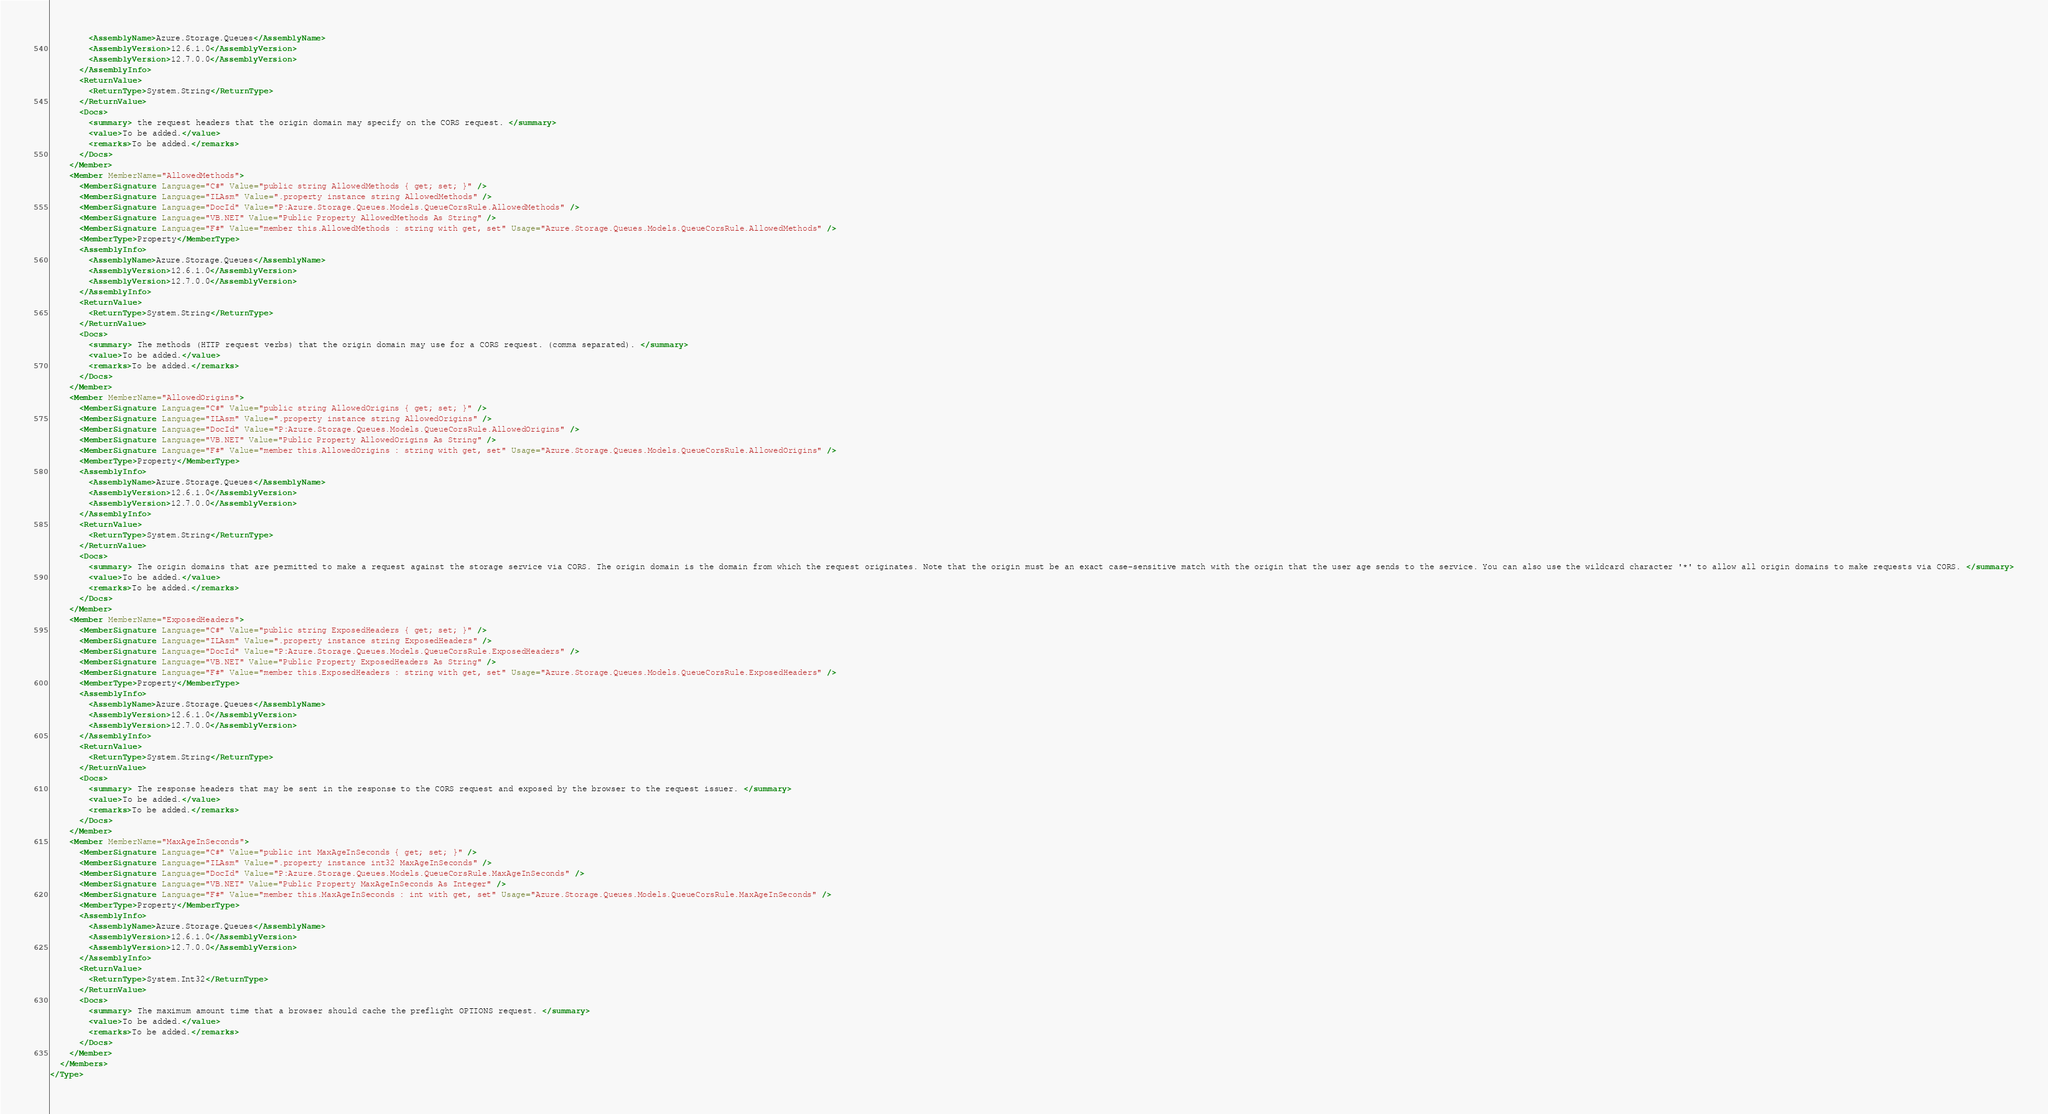Convert code to text. <code><loc_0><loc_0><loc_500><loc_500><_XML_>        <AssemblyName>Azure.Storage.Queues</AssemblyName>
        <AssemblyVersion>12.6.1.0</AssemblyVersion>
        <AssemblyVersion>12.7.0.0</AssemblyVersion>
      </AssemblyInfo>
      <ReturnValue>
        <ReturnType>System.String</ReturnType>
      </ReturnValue>
      <Docs>
        <summary> the request headers that the origin domain may specify on the CORS request. </summary>
        <value>To be added.</value>
        <remarks>To be added.</remarks>
      </Docs>
    </Member>
    <Member MemberName="AllowedMethods">
      <MemberSignature Language="C#" Value="public string AllowedMethods { get; set; }" />
      <MemberSignature Language="ILAsm" Value=".property instance string AllowedMethods" />
      <MemberSignature Language="DocId" Value="P:Azure.Storage.Queues.Models.QueueCorsRule.AllowedMethods" />
      <MemberSignature Language="VB.NET" Value="Public Property AllowedMethods As String" />
      <MemberSignature Language="F#" Value="member this.AllowedMethods : string with get, set" Usage="Azure.Storage.Queues.Models.QueueCorsRule.AllowedMethods" />
      <MemberType>Property</MemberType>
      <AssemblyInfo>
        <AssemblyName>Azure.Storage.Queues</AssemblyName>
        <AssemblyVersion>12.6.1.0</AssemblyVersion>
        <AssemblyVersion>12.7.0.0</AssemblyVersion>
      </AssemblyInfo>
      <ReturnValue>
        <ReturnType>System.String</ReturnType>
      </ReturnValue>
      <Docs>
        <summary> The methods (HTTP request verbs) that the origin domain may use for a CORS request. (comma separated). </summary>
        <value>To be added.</value>
        <remarks>To be added.</remarks>
      </Docs>
    </Member>
    <Member MemberName="AllowedOrigins">
      <MemberSignature Language="C#" Value="public string AllowedOrigins { get; set; }" />
      <MemberSignature Language="ILAsm" Value=".property instance string AllowedOrigins" />
      <MemberSignature Language="DocId" Value="P:Azure.Storage.Queues.Models.QueueCorsRule.AllowedOrigins" />
      <MemberSignature Language="VB.NET" Value="Public Property AllowedOrigins As String" />
      <MemberSignature Language="F#" Value="member this.AllowedOrigins : string with get, set" Usage="Azure.Storage.Queues.Models.QueueCorsRule.AllowedOrigins" />
      <MemberType>Property</MemberType>
      <AssemblyInfo>
        <AssemblyName>Azure.Storage.Queues</AssemblyName>
        <AssemblyVersion>12.6.1.0</AssemblyVersion>
        <AssemblyVersion>12.7.0.0</AssemblyVersion>
      </AssemblyInfo>
      <ReturnValue>
        <ReturnType>System.String</ReturnType>
      </ReturnValue>
      <Docs>
        <summary> The origin domains that are permitted to make a request against the storage service via CORS. The origin domain is the domain from which the request originates. Note that the origin must be an exact case-sensitive match with the origin that the user age sends to the service. You can also use the wildcard character '*' to allow all origin domains to make requests via CORS. </summary>
        <value>To be added.</value>
        <remarks>To be added.</remarks>
      </Docs>
    </Member>
    <Member MemberName="ExposedHeaders">
      <MemberSignature Language="C#" Value="public string ExposedHeaders { get; set; }" />
      <MemberSignature Language="ILAsm" Value=".property instance string ExposedHeaders" />
      <MemberSignature Language="DocId" Value="P:Azure.Storage.Queues.Models.QueueCorsRule.ExposedHeaders" />
      <MemberSignature Language="VB.NET" Value="Public Property ExposedHeaders As String" />
      <MemberSignature Language="F#" Value="member this.ExposedHeaders : string with get, set" Usage="Azure.Storage.Queues.Models.QueueCorsRule.ExposedHeaders" />
      <MemberType>Property</MemberType>
      <AssemblyInfo>
        <AssemblyName>Azure.Storage.Queues</AssemblyName>
        <AssemblyVersion>12.6.1.0</AssemblyVersion>
        <AssemblyVersion>12.7.0.0</AssemblyVersion>
      </AssemblyInfo>
      <ReturnValue>
        <ReturnType>System.String</ReturnType>
      </ReturnValue>
      <Docs>
        <summary> The response headers that may be sent in the response to the CORS request and exposed by the browser to the request issuer. </summary>
        <value>To be added.</value>
        <remarks>To be added.</remarks>
      </Docs>
    </Member>
    <Member MemberName="MaxAgeInSeconds">
      <MemberSignature Language="C#" Value="public int MaxAgeInSeconds { get; set; }" />
      <MemberSignature Language="ILAsm" Value=".property instance int32 MaxAgeInSeconds" />
      <MemberSignature Language="DocId" Value="P:Azure.Storage.Queues.Models.QueueCorsRule.MaxAgeInSeconds" />
      <MemberSignature Language="VB.NET" Value="Public Property MaxAgeInSeconds As Integer" />
      <MemberSignature Language="F#" Value="member this.MaxAgeInSeconds : int with get, set" Usage="Azure.Storage.Queues.Models.QueueCorsRule.MaxAgeInSeconds" />
      <MemberType>Property</MemberType>
      <AssemblyInfo>
        <AssemblyName>Azure.Storage.Queues</AssemblyName>
        <AssemblyVersion>12.6.1.0</AssemblyVersion>
        <AssemblyVersion>12.7.0.0</AssemblyVersion>
      </AssemblyInfo>
      <ReturnValue>
        <ReturnType>System.Int32</ReturnType>
      </ReturnValue>
      <Docs>
        <summary> The maximum amount time that a browser should cache the preflight OPTIONS request. </summary>
        <value>To be added.</value>
        <remarks>To be added.</remarks>
      </Docs>
    </Member>
  </Members>
</Type>
</code> 